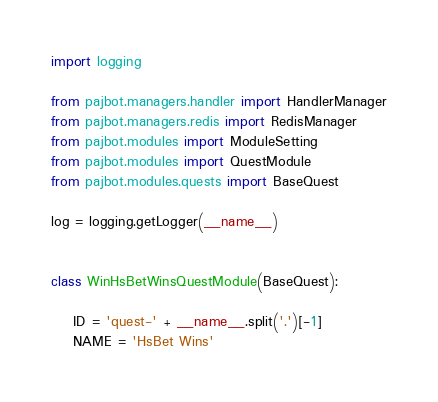Convert code to text. <code><loc_0><loc_0><loc_500><loc_500><_Python_>import logging

from pajbot.managers.handler import HandlerManager
from pajbot.managers.redis import RedisManager
from pajbot.modules import ModuleSetting
from pajbot.modules import QuestModule
from pajbot.modules.quests import BaseQuest

log = logging.getLogger(__name__)


class WinHsBetWinsQuestModule(BaseQuest):

    ID = 'quest-' + __name__.split('.')[-1]
    NAME = 'HsBet Wins'</code> 